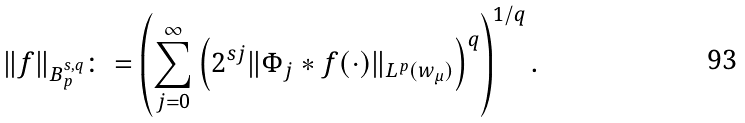<formula> <loc_0><loc_0><loc_500><loc_500>\| f \| _ { B ^ { s , q } _ { p } } \colon = \left ( \sum _ { j = 0 } ^ { \infty } \left ( 2 ^ { s j } \| \Phi _ { j } * f ( \cdot ) \| _ { L ^ { p } ( w _ { \mu } ) } \right ) ^ { q } \right ) ^ { 1 / q } .</formula> 